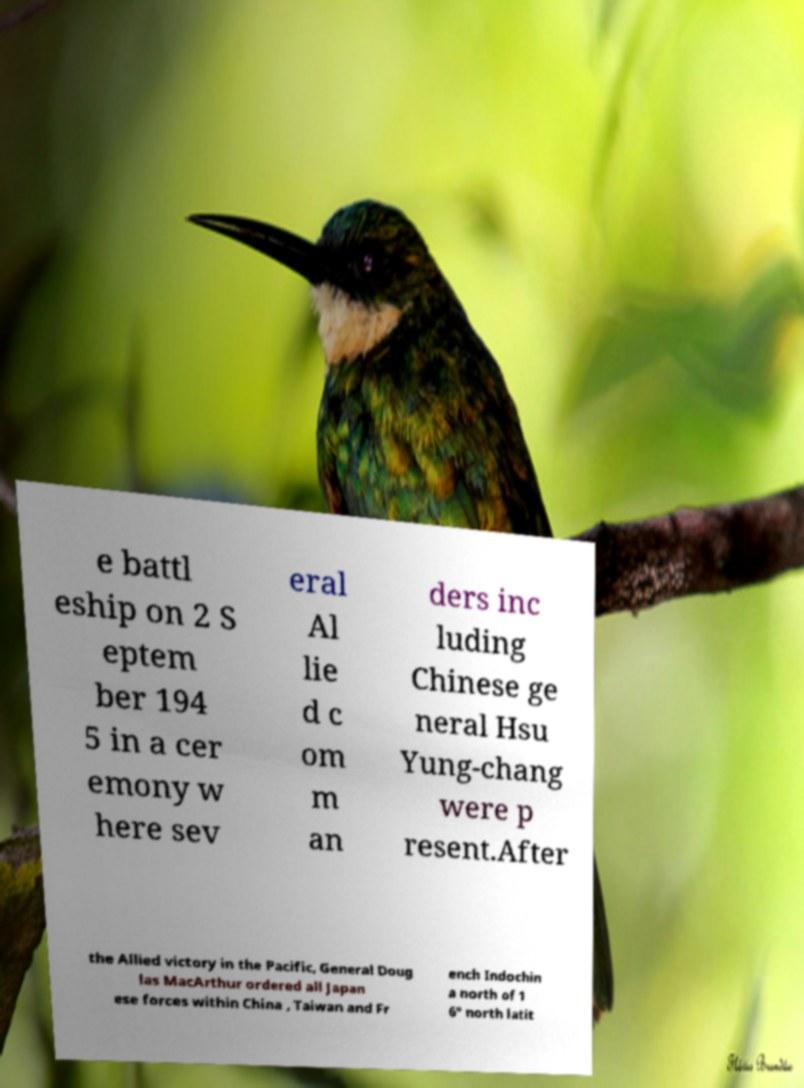Please identify and transcribe the text found in this image. e battl eship on 2 S eptem ber 194 5 in a cer emony w here sev eral Al lie d c om m an ders inc luding Chinese ge neral Hsu Yung-chang were p resent.After the Allied victory in the Pacific, General Doug las MacArthur ordered all Japan ese forces within China , Taiwan and Fr ench Indochin a north of 1 6° north latit 